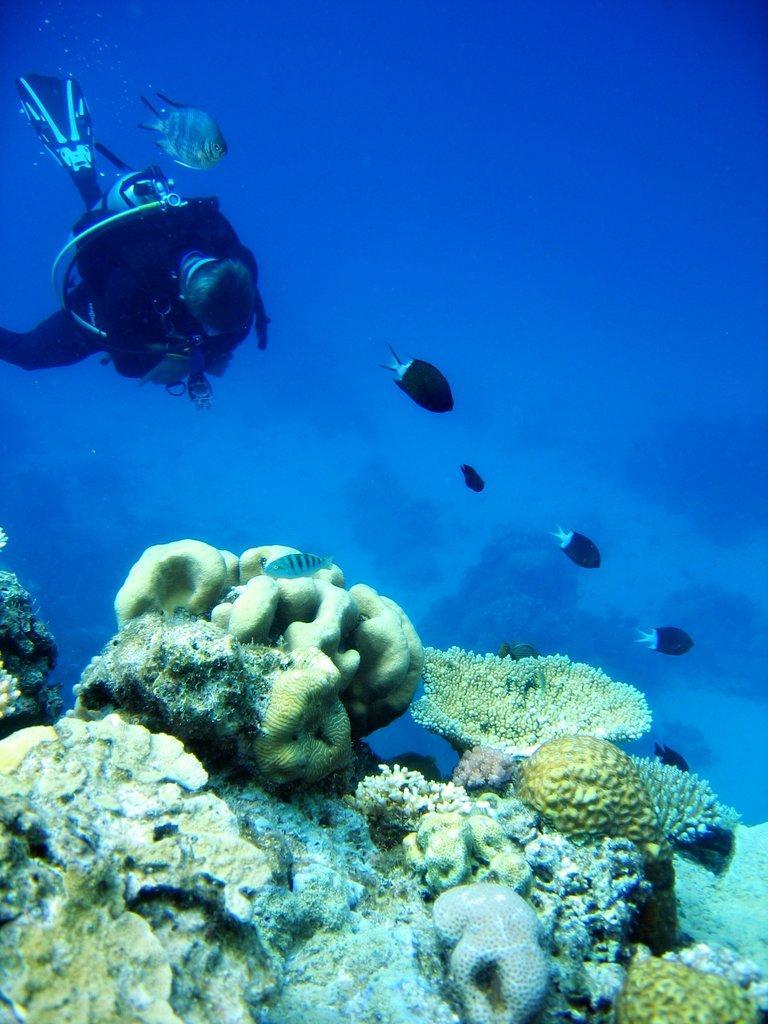In one or two sentences, can you explain what this image depicts? In this image there is a person in the water who is wearing the helmet,oxygen cylinder,gloves. In front of him there are fishes. At the bottom there are sea plants. 